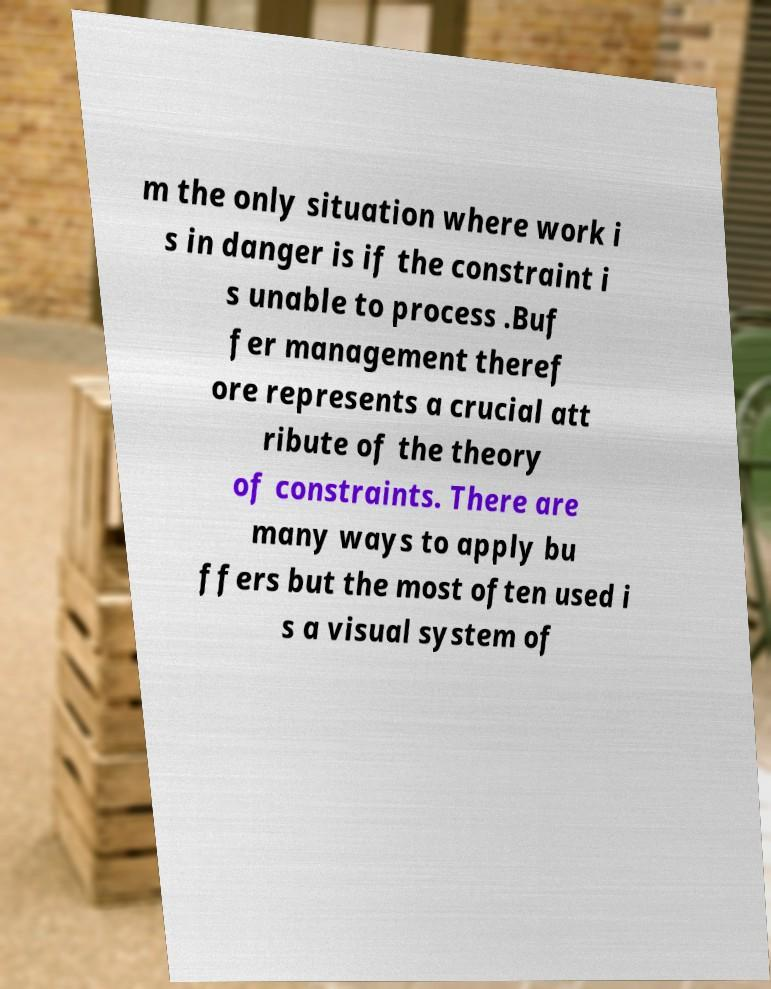Please identify and transcribe the text found in this image. m the only situation where work i s in danger is if the constraint i s unable to process .Buf fer management theref ore represents a crucial att ribute of the theory of constraints. There are many ways to apply bu ffers but the most often used i s a visual system of 